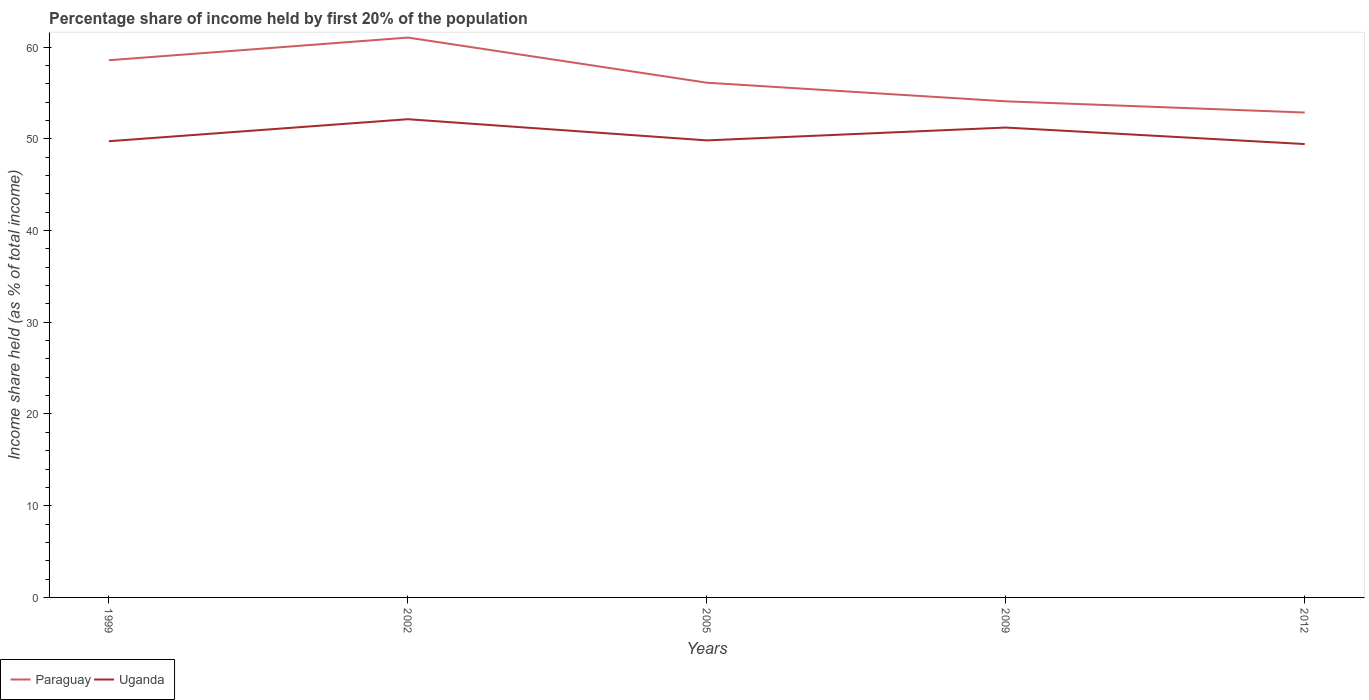How many different coloured lines are there?
Offer a terse response. 2. Does the line corresponding to Paraguay intersect with the line corresponding to Uganda?
Offer a very short reply. No. Is the number of lines equal to the number of legend labels?
Offer a very short reply. Yes. Across all years, what is the maximum share of income held by first 20% of the population in Uganda?
Provide a succinct answer. 49.43. In which year was the share of income held by first 20% of the population in Uganda maximum?
Ensure brevity in your answer.  2012. What is the total share of income held by first 20% of the population in Paraguay in the graph?
Provide a succinct answer. 4.48. What is the difference between the highest and the second highest share of income held by first 20% of the population in Paraguay?
Your answer should be very brief. 8.17. What is the difference between the highest and the lowest share of income held by first 20% of the population in Uganda?
Make the answer very short. 2. How many lines are there?
Provide a short and direct response. 2. What is the difference between two consecutive major ticks on the Y-axis?
Your response must be concise. 10. Are the values on the major ticks of Y-axis written in scientific E-notation?
Ensure brevity in your answer.  No. Does the graph contain any zero values?
Offer a very short reply. No. Does the graph contain grids?
Your answer should be very brief. No. Where does the legend appear in the graph?
Offer a very short reply. Bottom left. How many legend labels are there?
Your response must be concise. 2. What is the title of the graph?
Your response must be concise. Percentage share of income held by first 20% of the population. Does "Turkmenistan" appear as one of the legend labels in the graph?
Offer a very short reply. No. What is the label or title of the X-axis?
Give a very brief answer. Years. What is the label or title of the Y-axis?
Keep it short and to the point. Income share held (as % of total income). What is the Income share held (as % of total income) of Paraguay in 1999?
Give a very brief answer. 58.57. What is the Income share held (as % of total income) in Uganda in 1999?
Keep it short and to the point. 49.74. What is the Income share held (as % of total income) of Paraguay in 2002?
Provide a succinct answer. 61.04. What is the Income share held (as % of total income) of Uganda in 2002?
Make the answer very short. 52.14. What is the Income share held (as % of total income) of Paraguay in 2005?
Your answer should be compact. 56.12. What is the Income share held (as % of total income) in Uganda in 2005?
Offer a very short reply. 49.83. What is the Income share held (as % of total income) in Paraguay in 2009?
Keep it short and to the point. 54.09. What is the Income share held (as % of total income) of Uganda in 2009?
Keep it short and to the point. 51.23. What is the Income share held (as % of total income) of Paraguay in 2012?
Offer a terse response. 52.87. What is the Income share held (as % of total income) of Uganda in 2012?
Ensure brevity in your answer.  49.43. Across all years, what is the maximum Income share held (as % of total income) of Paraguay?
Your answer should be very brief. 61.04. Across all years, what is the maximum Income share held (as % of total income) of Uganda?
Provide a succinct answer. 52.14. Across all years, what is the minimum Income share held (as % of total income) of Paraguay?
Your answer should be compact. 52.87. Across all years, what is the minimum Income share held (as % of total income) of Uganda?
Your response must be concise. 49.43. What is the total Income share held (as % of total income) of Paraguay in the graph?
Your answer should be compact. 282.69. What is the total Income share held (as % of total income) in Uganda in the graph?
Offer a terse response. 252.37. What is the difference between the Income share held (as % of total income) in Paraguay in 1999 and that in 2002?
Offer a very short reply. -2.47. What is the difference between the Income share held (as % of total income) in Paraguay in 1999 and that in 2005?
Make the answer very short. 2.45. What is the difference between the Income share held (as % of total income) of Uganda in 1999 and that in 2005?
Provide a short and direct response. -0.09. What is the difference between the Income share held (as % of total income) in Paraguay in 1999 and that in 2009?
Make the answer very short. 4.48. What is the difference between the Income share held (as % of total income) in Uganda in 1999 and that in 2009?
Provide a succinct answer. -1.49. What is the difference between the Income share held (as % of total income) in Uganda in 1999 and that in 2012?
Offer a terse response. 0.31. What is the difference between the Income share held (as % of total income) of Paraguay in 2002 and that in 2005?
Make the answer very short. 4.92. What is the difference between the Income share held (as % of total income) of Uganda in 2002 and that in 2005?
Ensure brevity in your answer.  2.31. What is the difference between the Income share held (as % of total income) of Paraguay in 2002 and that in 2009?
Your answer should be very brief. 6.95. What is the difference between the Income share held (as % of total income) of Uganda in 2002 and that in 2009?
Provide a short and direct response. 0.91. What is the difference between the Income share held (as % of total income) in Paraguay in 2002 and that in 2012?
Ensure brevity in your answer.  8.17. What is the difference between the Income share held (as % of total income) in Uganda in 2002 and that in 2012?
Keep it short and to the point. 2.71. What is the difference between the Income share held (as % of total income) in Paraguay in 2005 and that in 2009?
Make the answer very short. 2.03. What is the difference between the Income share held (as % of total income) of Paraguay in 2005 and that in 2012?
Provide a short and direct response. 3.25. What is the difference between the Income share held (as % of total income) in Paraguay in 2009 and that in 2012?
Your response must be concise. 1.22. What is the difference between the Income share held (as % of total income) of Paraguay in 1999 and the Income share held (as % of total income) of Uganda in 2002?
Provide a short and direct response. 6.43. What is the difference between the Income share held (as % of total income) of Paraguay in 1999 and the Income share held (as % of total income) of Uganda in 2005?
Provide a short and direct response. 8.74. What is the difference between the Income share held (as % of total income) of Paraguay in 1999 and the Income share held (as % of total income) of Uganda in 2009?
Make the answer very short. 7.34. What is the difference between the Income share held (as % of total income) of Paraguay in 1999 and the Income share held (as % of total income) of Uganda in 2012?
Your response must be concise. 9.14. What is the difference between the Income share held (as % of total income) in Paraguay in 2002 and the Income share held (as % of total income) in Uganda in 2005?
Make the answer very short. 11.21. What is the difference between the Income share held (as % of total income) of Paraguay in 2002 and the Income share held (as % of total income) of Uganda in 2009?
Your answer should be very brief. 9.81. What is the difference between the Income share held (as % of total income) of Paraguay in 2002 and the Income share held (as % of total income) of Uganda in 2012?
Give a very brief answer. 11.61. What is the difference between the Income share held (as % of total income) of Paraguay in 2005 and the Income share held (as % of total income) of Uganda in 2009?
Make the answer very short. 4.89. What is the difference between the Income share held (as % of total income) in Paraguay in 2005 and the Income share held (as % of total income) in Uganda in 2012?
Your answer should be compact. 6.69. What is the difference between the Income share held (as % of total income) of Paraguay in 2009 and the Income share held (as % of total income) of Uganda in 2012?
Ensure brevity in your answer.  4.66. What is the average Income share held (as % of total income) of Paraguay per year?
Your answer should be compact. 56.54. What is the average Income share held (as % of total income) of Uganda per year?
Offer a terse response. 50.47. In the year 1999, what is the difference between the Income share held (as % of total income) of Paraguay and Income share held (as % of total income) of Uganda?
Your answer should be compact. 8.83. In the year 2002, what is the difference between the Income share held (as % of total income) in Paraguay and Income share held (as % of total income) in Uganda?
Keep it short and to the point. 8.9. In the year 2005, what is the difference between the Income share held (as % of total income) in Paraguay and Income share held (as % of total income) in Uganda?
Your answer should be very brief. 6.29. In the year 2009, what is the difference between the Income share held (as % of total income) of Paraguay and Income share held (as % of total income) of Uganda?
Keep it short and to the point. 2.86. In the year 2012, what is the difference between the Income share held (as % of total income) in Paraguay and Income share held (as % of total income) in Uganda?
Your answer should be compact. 3.44. What is the ratio of the Income share held (as % of total income) in Paraguay in 1999 to that in 2002?
Give a very brief answer. 0.96. What is the ratio of the Income share held (as % of total income) of Uganda in 1999 to that in 2002?
Your response must be concise. 0.95. What is the ratio of the Income share held (as % of total income) in Paraguay in 1999 to that in 2005?
Provide a short and direct response. 1.04. What is the ratio of the Income share held (as % of total income) in Uganda in 1999 to that in 2005?
Keep it short and to the point. 1. What is the ratio of the Income share held (as % of total income) of Paraguay in 1999 to that in 2009?
Your answer should be compact. 1.08. What is the ratio of the Income share held (as % of total income) in Uganda in 1999 to that in 2009?
Provide a short and direct response. 0.97. What is the ratio of the Income share held (as % of total income) in Paraguay in 1999 to that in 2012?
Your answer should be very brief. 1.11. What is the ratio of the Income share held (as % of total income) of Paraguay in 2002 to that in 2005?
Provide a short and direct response. 1.09. What is the ratio of the Income share held (as % of total income) in Uganda in 2002 to that in 2005?
Your response must be concise. 1.05. What is the ratio of the Income share held (as % of total income) in Paraguay in 2002 to that in 2009?
Provide a short and direct response. 1.13. What is the ratio of the Income share held (as % of total income) of Uganda in 2002 to that in 2009?
Provide a succinct answer. 1.02. What is the ratio of the Income share held (as % of total income) in Paraguay in 2002 to that in 2012?
Provide a succinct answer. 1.15. What is the ratio of the Income share held (as % of total income) in Uganda in 2002 to that in 2012?
Provide a short and direct response. 1.05. What is the ratio of the Income share held (as % of total income) in Paraguay in 2005 to that in 2009?
Ensure brevity in your answer.  1.04. What is the ratio of the Income share held (as % of total income) in Uganda in 2005 to that in 2009?
Offer a very short reply. 0.97. What is the ratio of the Income share held (as % of total income) of Paraguay in 2005 to that in 2012?
Your response must be concise. 1.06. What is the ratio of the Income share held (as % of total income) of Paraguay in 2009 to that in 2012?
Keep it short and to the point. 1.02. What is the ratio of the Income share held (as % of total income) in Uganda in 2009 to that in 2012?
Your answer should be compact. 1.04. What is the difference between the highest and the second highest Income share held (as % of total income) of Paraguay?
Make the answer very short. 2.47. What is the difference between the highest and the second highest Income share held (as % of total income) in Uganda?
Make the answer very short. 0.91. What is the difference between the highest and the lowest Income share held (as % of total income) of Paraguay?
Ensure brevity in your answer.  8.17. What is the difference between the highest and the lowest Income share held (as % of total income) in Uganda?
Provide a succinct answer. 2.71. 